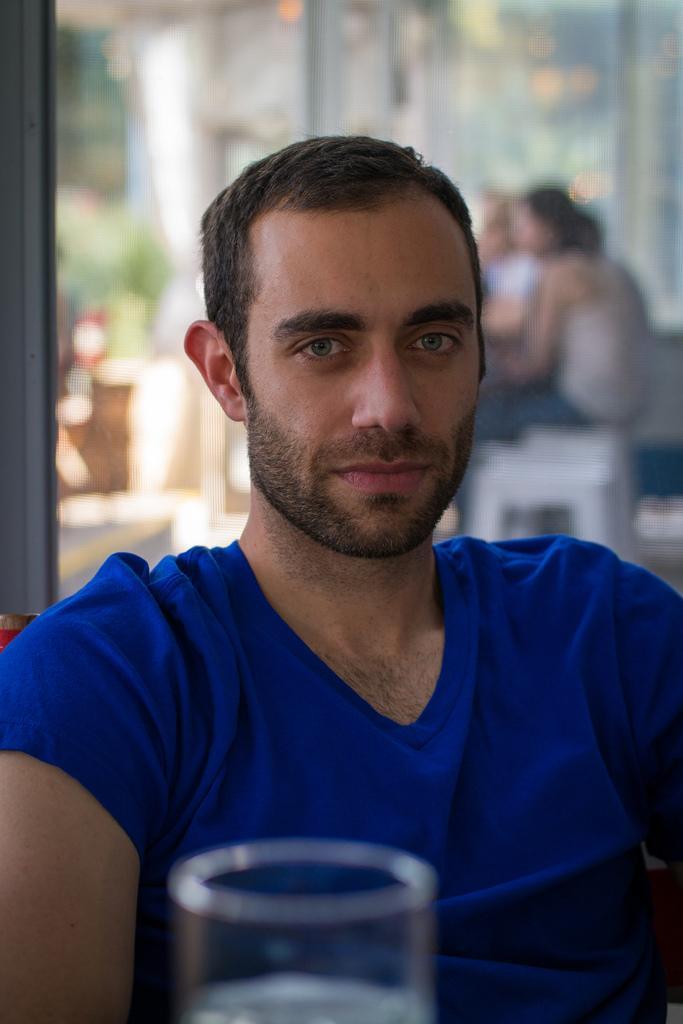Please provide a concise description of this image. In this image, we can see a person wearing T-shirt. We can also see a glass with some liquid. We can also see the blurred background. 